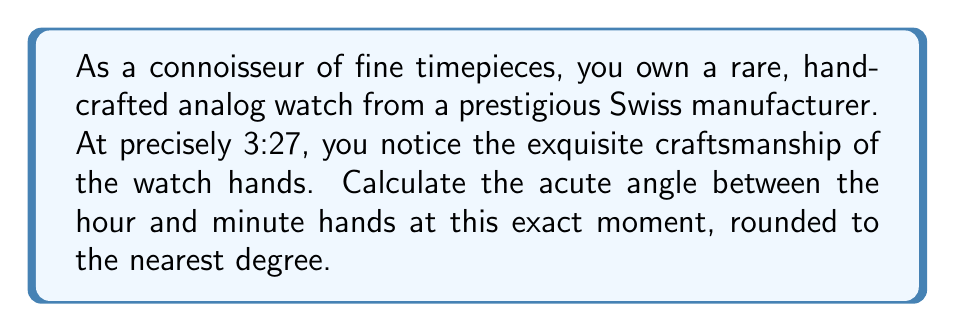Can you solve this math problem? Let's approach this step-by-step:

1) First, we need to understand how the watch hands move:
   - The hour hand makes a complete 360° rotation in 12 hours, or 30° per hour.
   - The minute hand makes a complete 360° rotation in 60 minutes, or 6° per minute.

2) At 3:27, we need to calculate the position of each hand:

   Hour hand:
   - 3 hours have passed, so it has moved 3 * 30° = 90° from the 12 o'clock position.
   - Additionally, it moves a fraction for the extra 27 minutes: 27/60 * 30° = 13.5°
   - Total angle for hour hand: 90° + 13.5° = 103.5°

   Minute hand:
   - 27 minutes have passed, so it has moved 27 * 6° = 162° from the 12 o'clock position.

3) The acute angle between the hands is the absolute difference between these angles:
   
   $$|\text{Angle}_\text{minute} - \text{Angle}_\text{hour}| = |162° - 103.5°| = 58.5°$$

4) Rounding to the nearest degree:
   58.5° rounds to 59°
Answer: 59° 